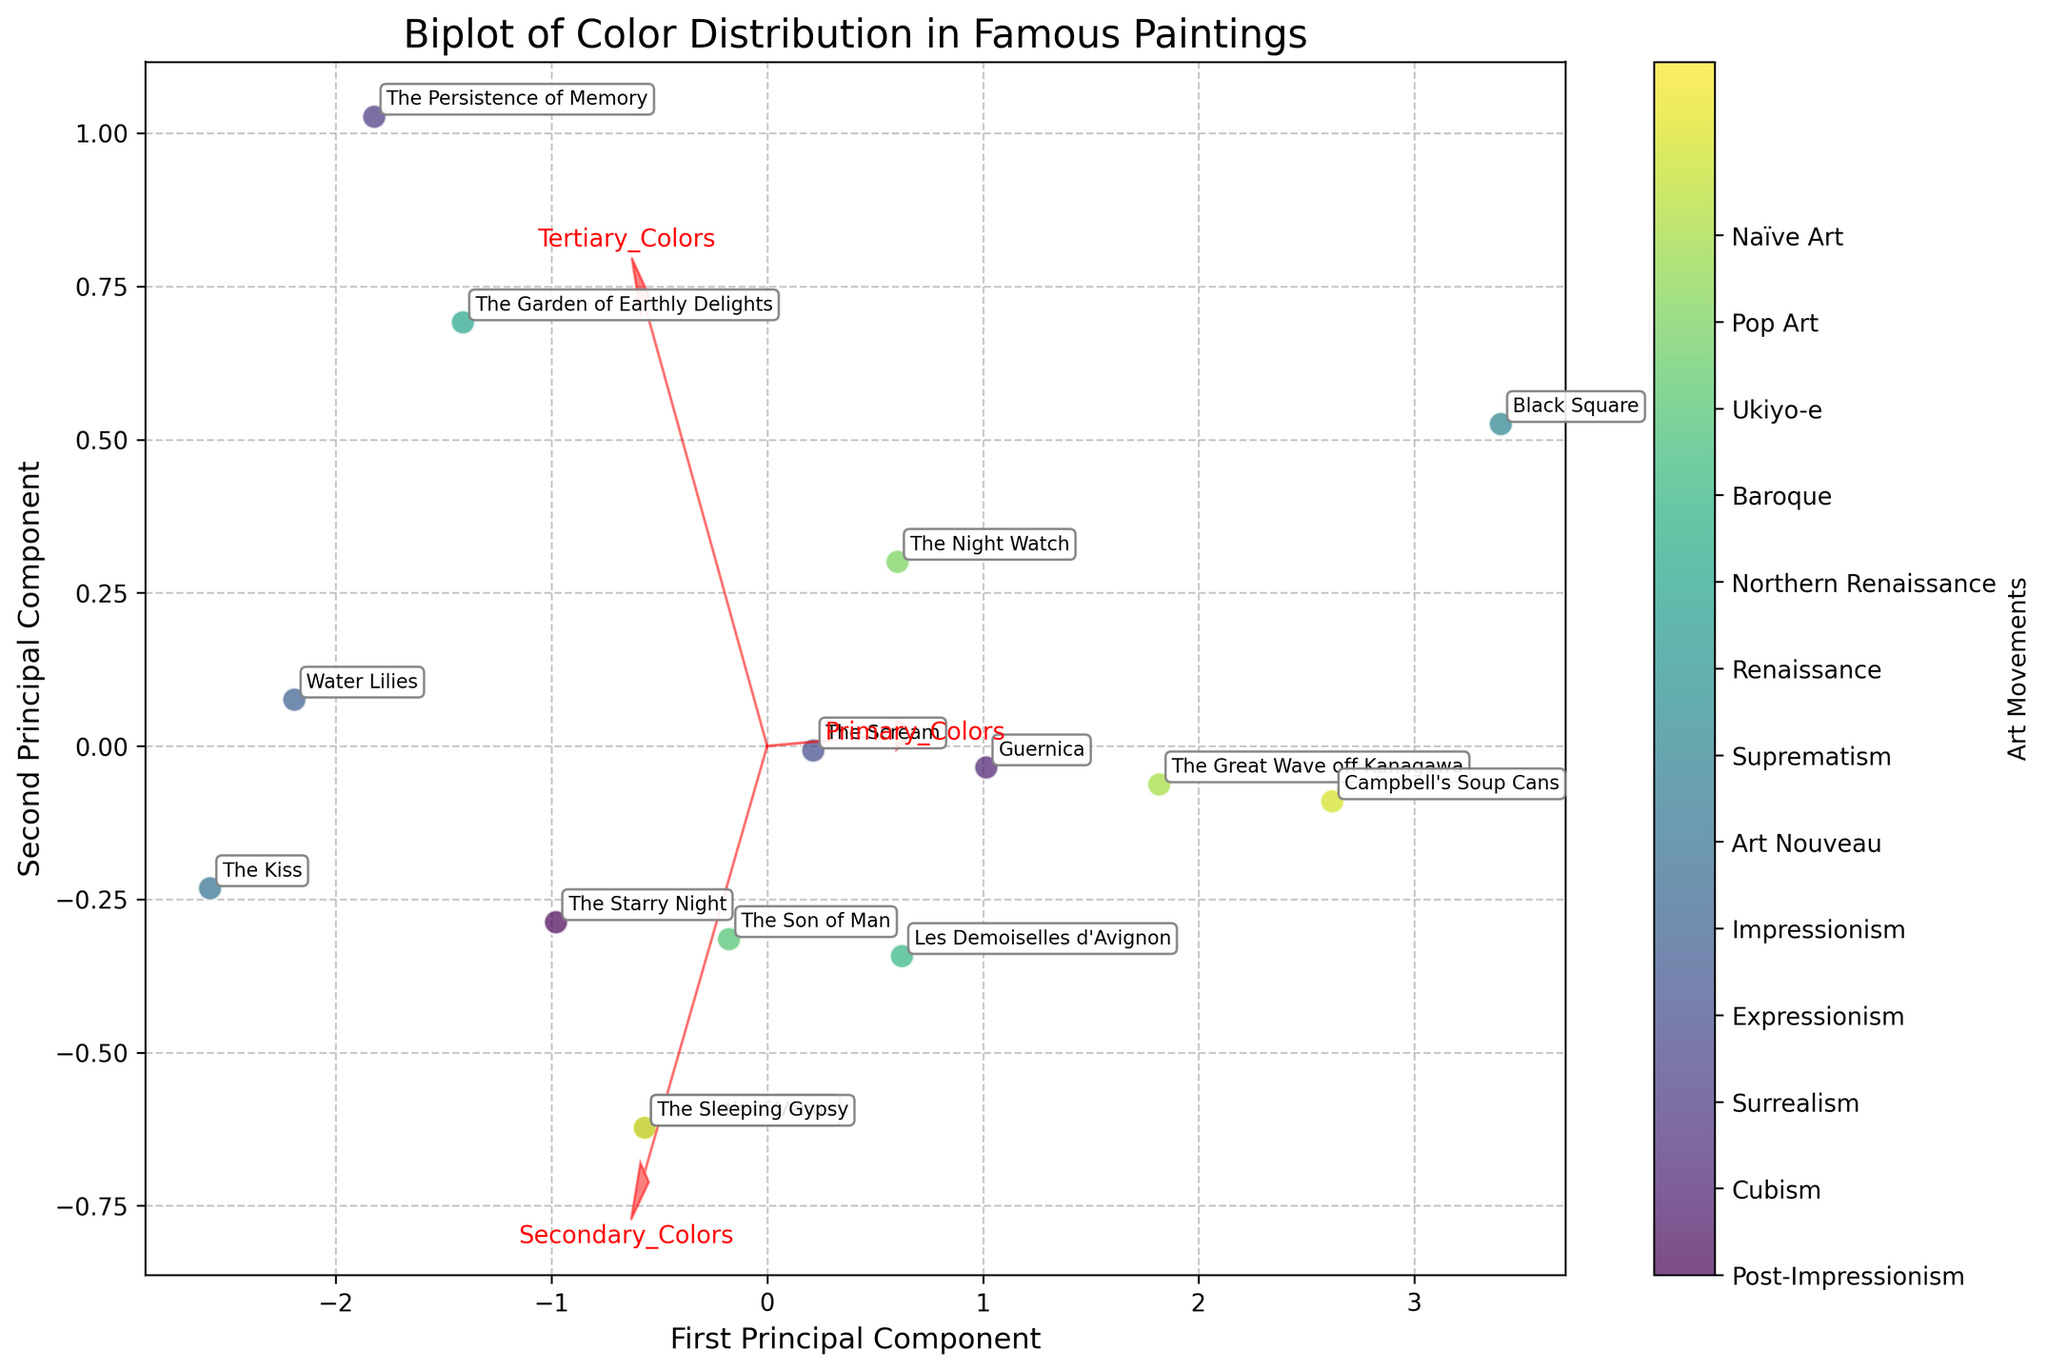What is the title of the biplot? The title is typically placed at the top of the figure, indicating the main subject or focus.
Answer: Biplot of Color Distribution in Famous Paintings How many principal components are shown along the axes? The axes are marked with labels indicating the principal components derived from the PCA analysis.
Answer: Two Which painting is closest to the first principal component's positive direction? The points are labeled with painting names and their relative position along the principal components will lead us to the answer.
Answer: Black Square Which painting has the highest value for tertiary colors based on its position in the biplot? By looking at the direction and length of the arrow labeled 'Tertiary_Colors,' we can infer the painting closest to the positive direction of this vector.
Answer: The Persistence of Memory How are 'Primary_Colors' and 'Secondary_Colors' related based on their vectors in the biplot? Analyze the angle between the vectors representing 'Primary_Colors' and 'Secondary_Colors.' If they form an acute angle, they are positively correlated; if an obtuse angle, negatively correlated.
Answer: Positively correlated Which movement seems to use a balanced distribution of primary, secondary, and tertiary colors? Look at the paintings located near the origin, which signals a balanced use of the three color types.
Answer: Impressionism (for Water Lilies) Compare the use of primary colors in Post-Impressionism and Suprematism based on the biplot. Look at the positions of the points representing paintings from these movements relative to the 'Primary_Colors' vector.
Answer: Suprematism uses more primary colors Which vectors point in the same general direction, indicating a similar effect on principal components? Vectors that are closely aligned or parallel are pointing in the same general direction.
Answer: Primary_Colors and Secondary_Colors Estimate the relative composition of the painting "The Garden of Earthly Delights" based on its position in the biplot. Its position relative to the vectors of primary, secondary, and tertiary colors suggests its composition.
Answer: Balanced among all three How does "The Birth of Venus" compare to "The Starry Night" in terms of secondary colors? Looking at their positions relative to the 'Secondary_Colors' vector gives the answer.
Answer: Similar (both are near the vector) 